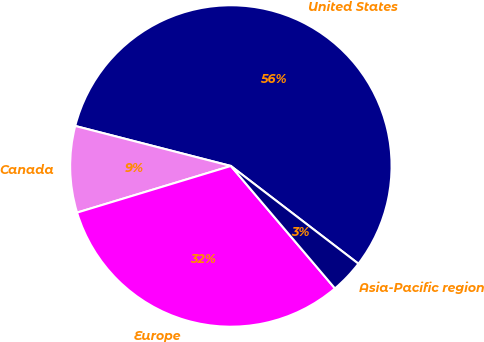Convert chart. <chart><loc_0><loc_0><loc_500><loc_500><pie_chart><fcel>United States<fcel>Canada<fcel>Europe<fcel>Asia-Pacific region<nl><fcel>56.4%<fcel>8.69%<fcel>31.53%<fcel>3.38%<nl></chart> 